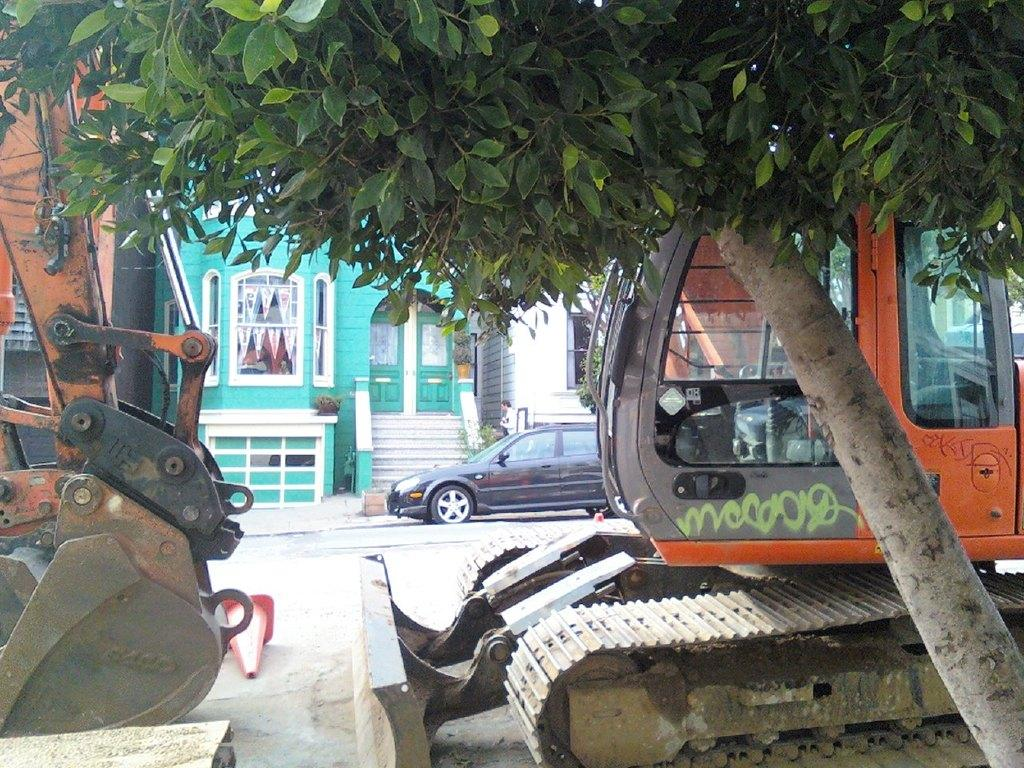What type of objects are present in the image? There are machines, a car, and a building in the image. Can you describe the natural element in the image? There is a tree on the right side of the image. What position does the car take in relation to the machines in the image? The position of the car in relation to the machines cannot be determined from the image alone, as there is no information about their relative positions. 